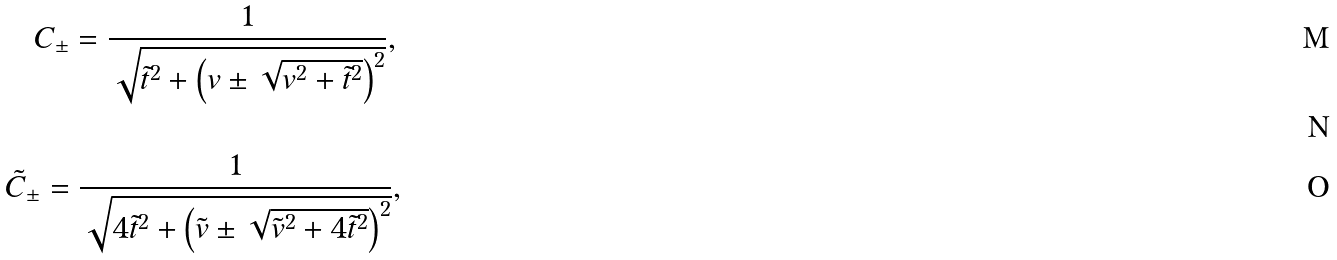Convert formula to latex. <formula><loc_0><loc_0><loc_500><loc_500>C _ { \pm } = \frac { 1 } { { \sqrt { \tilde { t } ^ { 2 } + \left ( { v \pm \sqrt { v ^ { 2 } + \tilde { t } ^ { 2 } } } \right ) ^ { 2 } } } } , \, \\ \\ \ \tilde { C } _ { \pm } = \frac { 1 } { { \sqrt { 4 \tilde { t } ^ { 2 } + \left ( { \tilde { v } \pm \sqrt { \tilde { v } ^ { 2 } + 4 \tilde { t } ^ { 2 } } } \right ) ^ { 2 } } } } ,</formula> 